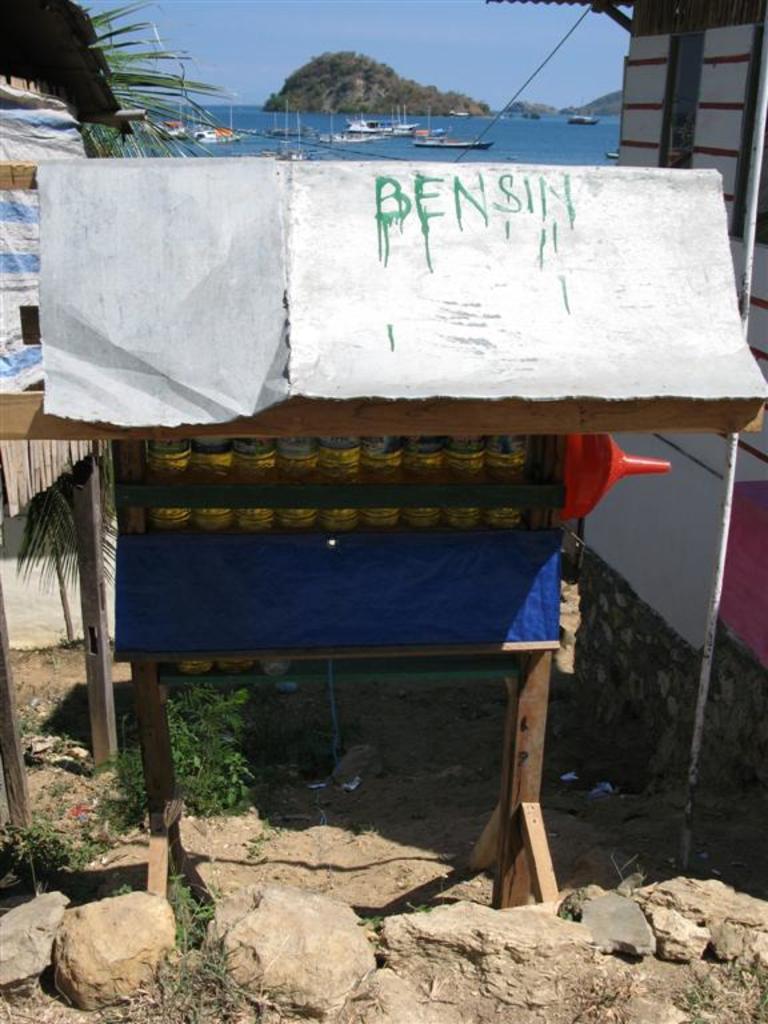Can you describe this image briefly? In this image, there is an outside view. There is a rack in the middle of the image contains some bottles. There is sea and sky at the top of the image. 